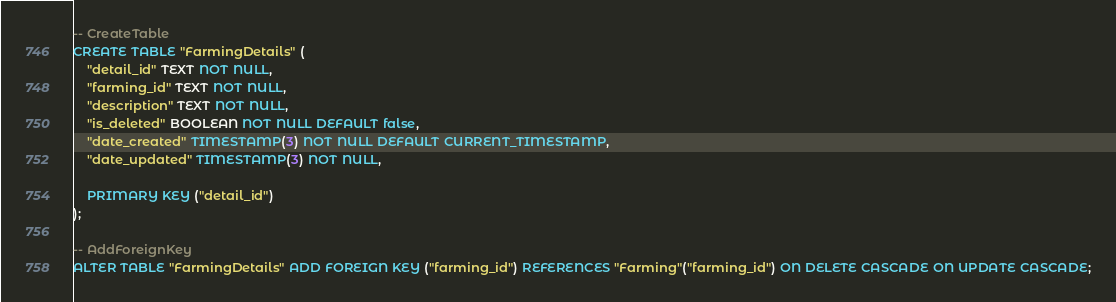<code> <loc_0><loc_0><loc_500><loc_500><_SQL_>-- CreateTable
CREATE TABLE "FarmingDetails" (
    "detail_id" TEXT NOT NULL,
    "farming_id" TEXT NOT NULL,
    "description" TEXT NOT NULL,
    "is_deleted" BOOLEAN NOT NULL DEFAULT false,
    "date_created" TIMESTAMP(3) NOT NULL DEFAULT CURRENT_TIMESTAMP,
    "date_updated" TIMESTAMP(3) NOT NULL,

    PRIMARY KEY ("detail_id")
);

-- AddForeignKey
ALTER TABLE "FarmingDetails" ADD FOREIGN KEY ("farming_id") REFERENCES "Farming"("farming_id") ON DELETE CASCADE ON UPDATE CASCADE;
</code> 